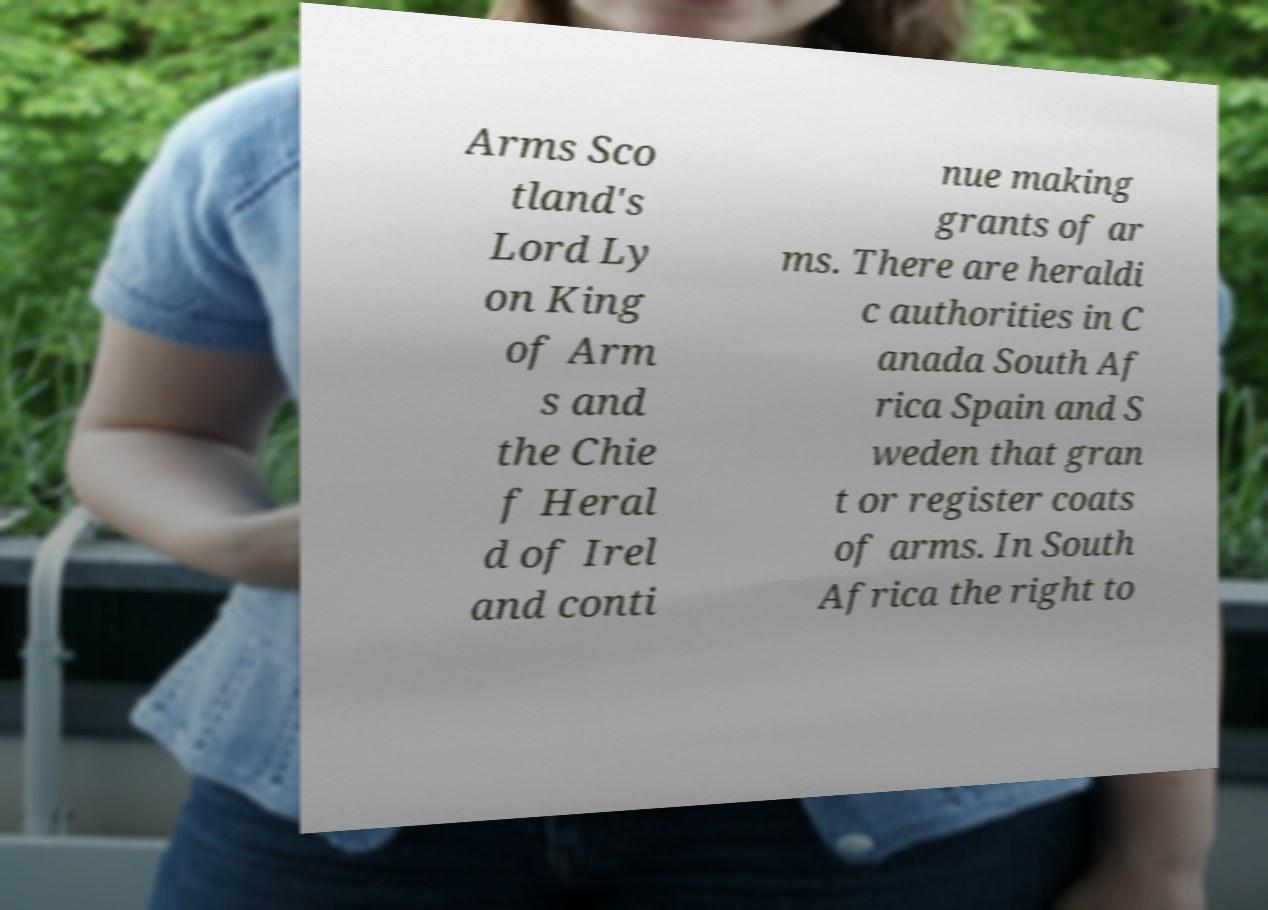There's text embedded in this image that I need extracted. Can you transcribe it verbatim? Arms Sco tland's Lord Ly on King of Arm s and the Chie f Heral d of Irel and conti nue making grants of ar ms. There are heraldi c authorities in C anada South Af rica Spain and S weden that gran t or register coats of arms. In South Africa the right to 